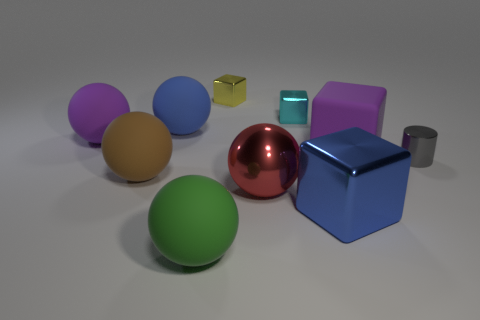Subtract all yellow metallic cubes. How many cubes are left? 3 Subtract all green balls. How many balls are left? 4 Subtract 3 balls. How many balls are left? 2 Subtract all blue cylinders. How many green balls are left? 1 Subtract all brown spheres. Subtract all tiny blocks. How many objects are left? 7 Add 3 blocks. How many blocks are left? 7 Add 9 large yellow rubber blocks. How many large yellow rubber blocks exist? 9 Subtract 0 blue cylinders. How many objects are left? 10 Subtract all cylinders. How many objects are left? 9 Subtract all blue spheres. Subtract all gray cubes. How many spheres are left? 4 